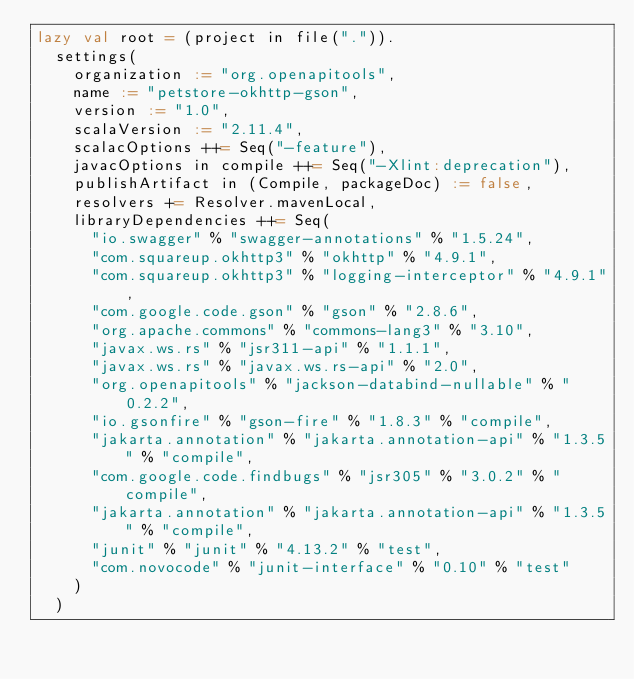Convert code to text. <code><loc_0><loc_0><loc_500><loc_500><_Scala_>lazy val root = (project in file(".")).
  settings(
    organization := "org.openapitools",
    name := "petstore-okhttp-gson",
    version := "1.0",
    scalaVersion := "2.11.4",
    scalacOptions ++= Seq("-feature"),
    javacOptions in compile ++= Seq("-Xlint:deprecation"),
    publishArtifact in (Compile, packageDoc) := false,
    resolvers += Resolver.mavenLocal,
    libraryDependencies ++= Seq(
      "io.swagger" % "swagger-annotations" % "1.5.24",
      "com.squareup.okhttp3" % "okhttp" % "4.9.1",
      "com.squareup.okhttp3" % "logging-interceptor" % "4.9.1",
      "com.google.code.gson" % "gson" % "2.8.6",
      "org.apache.commons" % "commons-lang3" % "3.10",
      "javax.ws.rs" % "jsr311-api" % "1.1.1",
      "javax.ws.rs" % "javax.ws.rs-api" % "2.0",
      "org.openapitools" % "jackson-databind-nullable" % "0.2.2",
      "io.gsonfire" % "gson-fire" % "1.8.3" % "compile",
      "jakarta.annotation" % "jakarta.annotation-api" % "1.3.5" % "compile",
      "com.google.code.findbugs" % "jsr305" % "3.0.2" % "compile",
      "jakarta.annotation" % "jakarta.annotation-api" % "1.3.5" % "compile",
      "junit" % "junit" % "4.13.2" % "test",
      "com.novocode" % "junit-interface" % "0.10" % "test"
    )
  )
</code> 